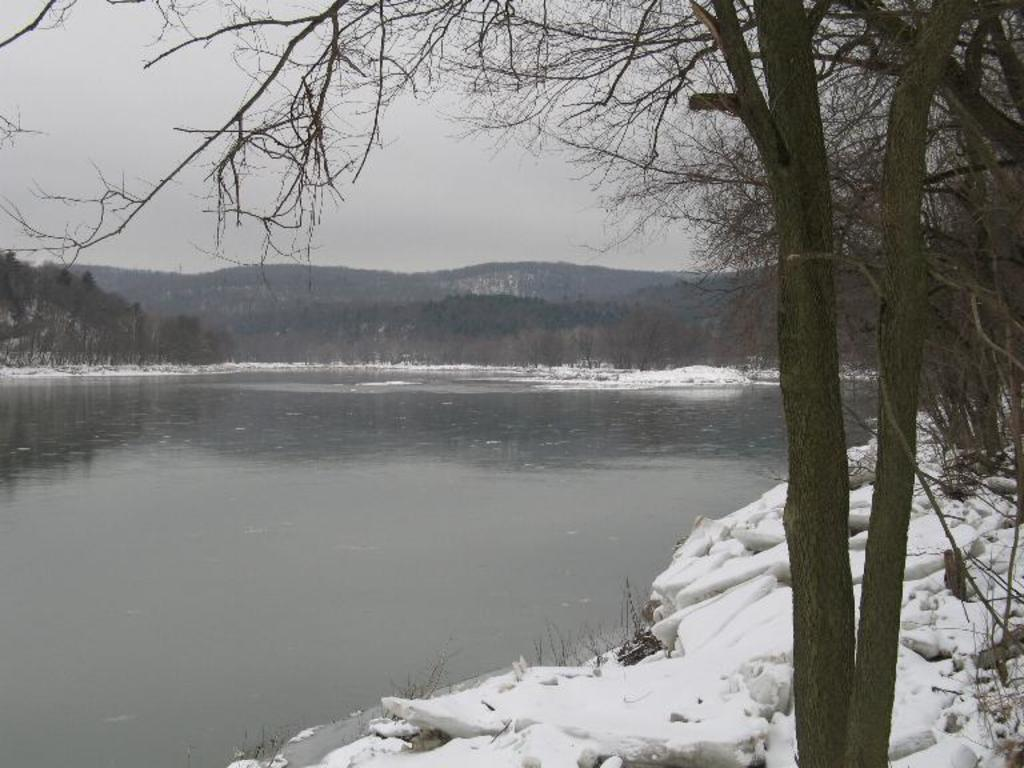What is one of the natural elements present in the image? There is water in the image. What type of weather condition can be observed in the image? There is snow in the image, indicating a cold or wintry condition. What type of vegetation is present in the image? There are trees in the image. What is visible in the sky in the image? There are clouds visible in the sky. What type of screw can be seen in the image? There is no screw present in the image. What type of cooking utensil can be seen in the image? There is no cooking utensil present in the image. 